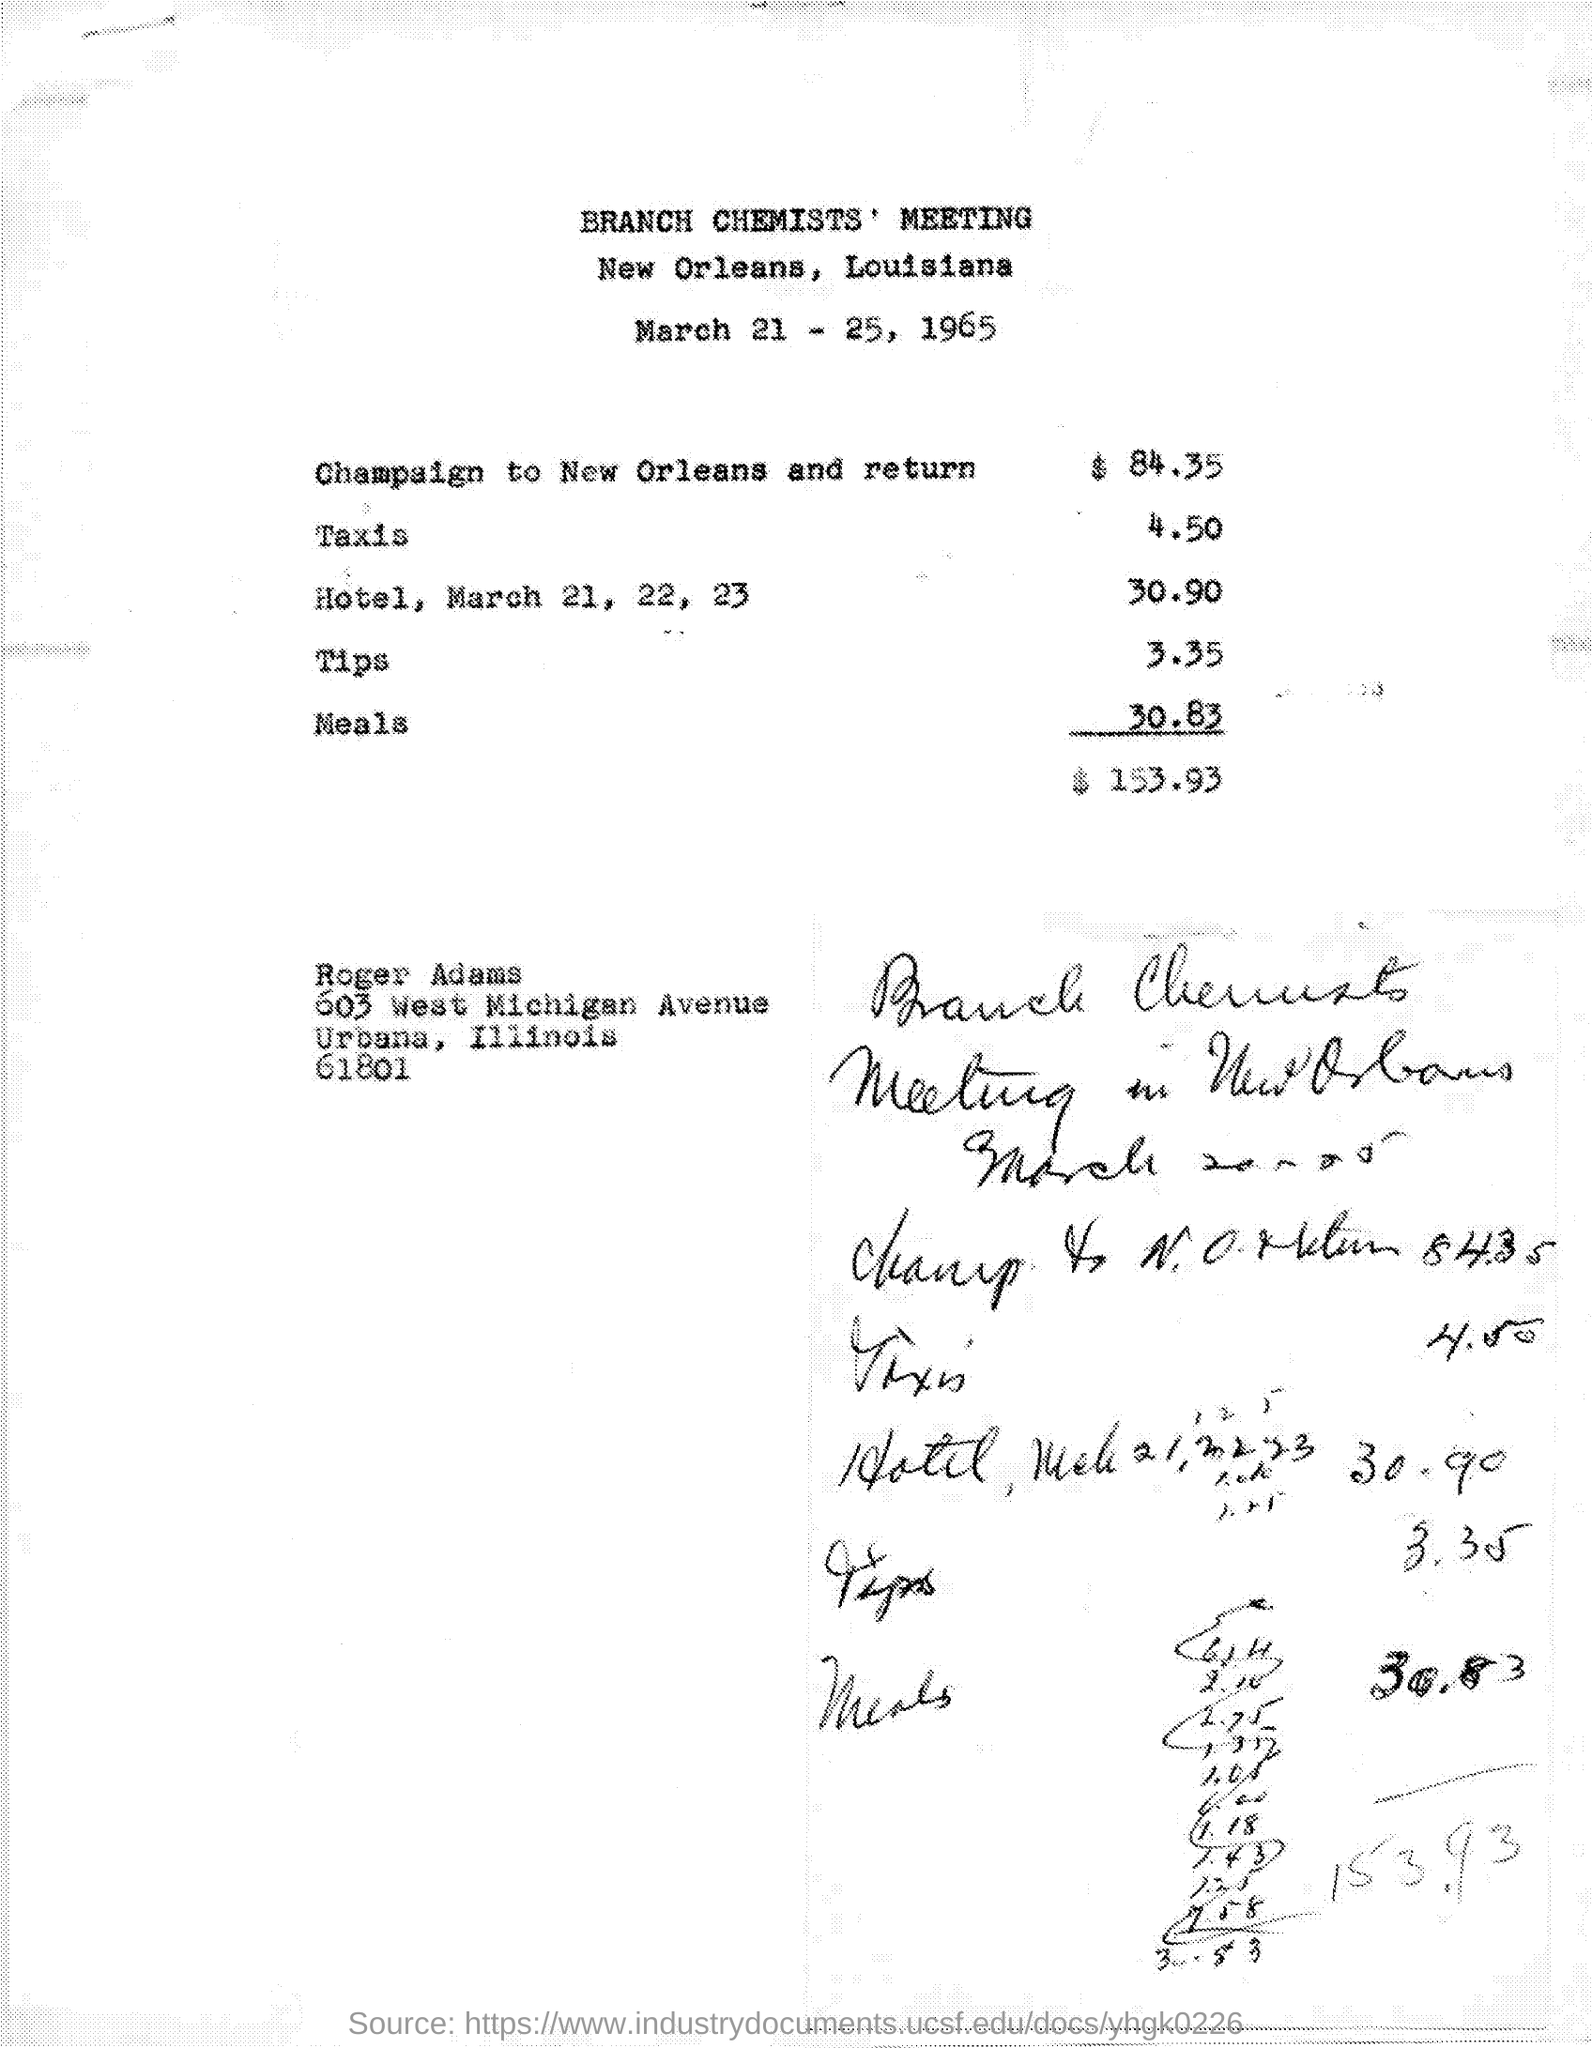What are the expenses for champaign to new orleans and return as mentioned in the given letter ?
Keep it short and to the point. 84.35. What is the cost of taxis ?
Your answer should be compact. 4.50. What is the cost of hotel,on march 21,22,23 ?
Offer a terse response. 30.90. What are the expenses for tips mentioned in the given page ?
Make the answer very short. 3.35. What is the cost of meals ?
Provide a short and direct response. 30.83. What are the total expenses mentioned in the given page ?
Provide a short and direct response. $ 153.93. 